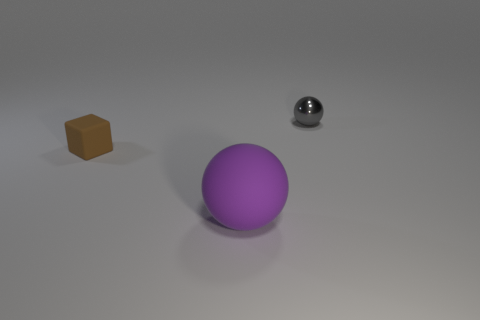Subtract all purple spheres. How many spheres are left? 1 Add 3 gray metallic cubes. How many objects exist? 6 Subtract all cubes. How many objects are left? 2 Subtract all purple spheres. Subtract all brown cubes. How many spheres are left? 1 Subtract all brown cylinders. How many purple cubes are left? 0 Subtract all small shiny objects. Subtract all spheres. How many objects are left? 0 Add 3 purple spheres. How many purple spheres are left? 4 Add 2 tiny gray spheres. How many tiny gray spheres exist? 3 Subtract 0 green blocks. How many objects are left? 3 